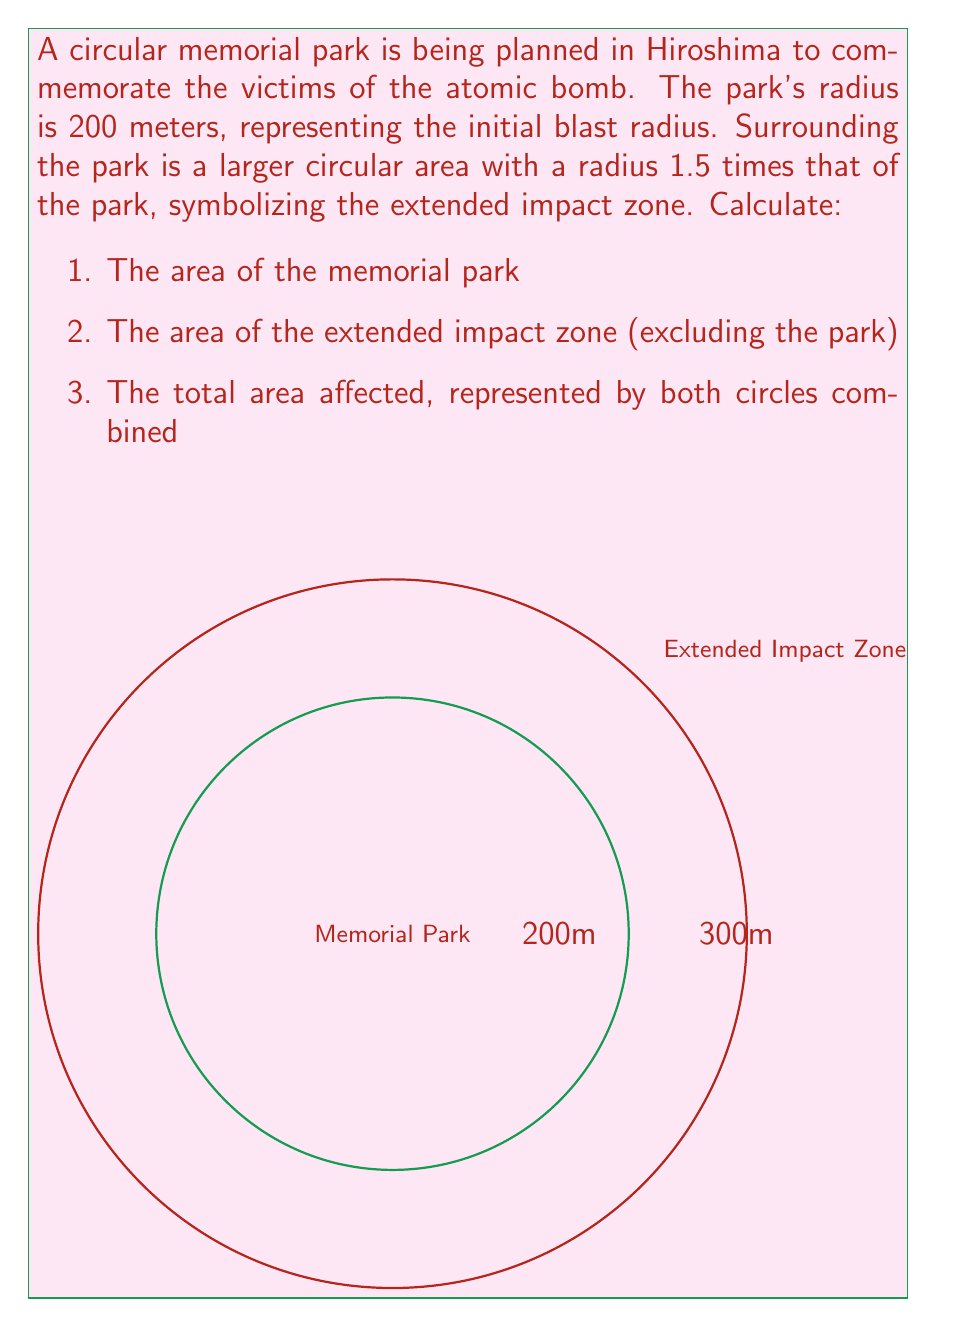Solve this math problem. Let's approach this step-by-step:

1) Area of the memorial park:
   The formula for the area of a circle is $A = \pi r^2$
   Radius of the park = 200 m
   $$A_{\text{park}} = \pi (200)^2 = 40,000\pi \approx 125,663.71 \text{ m}^2$$

2) Area of the extended impact zone:
   Radius of the extended zone = 1.5 * 200 = 300 m
   First, calculate the total area of the larger circle:
   $$A_{\text{total}} = \pi (300)^2 = 90,000\pi \approx 282,743.34 \text{ m}^2$$
   Then subtract the area of the park:
   $$A_{\text{extended}} = 90,000\pi - 40,000\pi = 50,000\pi \approx 157,079.63 \text{ m}^2$$

3) Total affected area:
   This is simply the area of the larger circle:
   $$A_{\text{affected}} = 90,000\pi \approx 282,743.34 \text{ m}^2$$
Answer: 1) $40,000\pi \text{ m}^2$
2) $50,000\pi \text{ m}^2$
3) $90,000\pi \text{ m}^2$ 